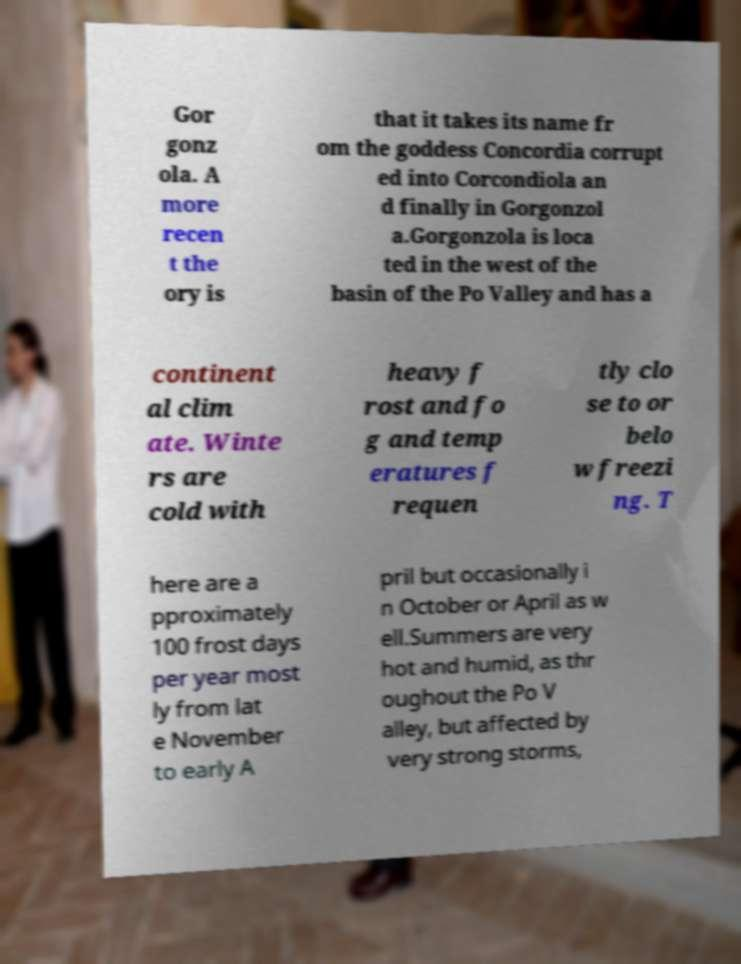Please identify and transcribe the text found in this image. Gor gonz ola. A more recen t the ory is that it takes its name fr om the goddess Concordia corrupt ed into Corcondiola an d finally in Gorgonzol a.Gorgonzola is loca ted in the west of the basin of the Po Valley and has a continent al clim ate. Winte rs are cold with heavy f rost and fo g and temp eratures f requen tly clo se to or belo w freezi ng. T here are a pproximately 100 frost days per year most ly from lat e November to early A pril but occasionally i n October or April as w ell.Summers are very hot and humid, as thr oughout the Po V alley, but affected by very strong storms, 